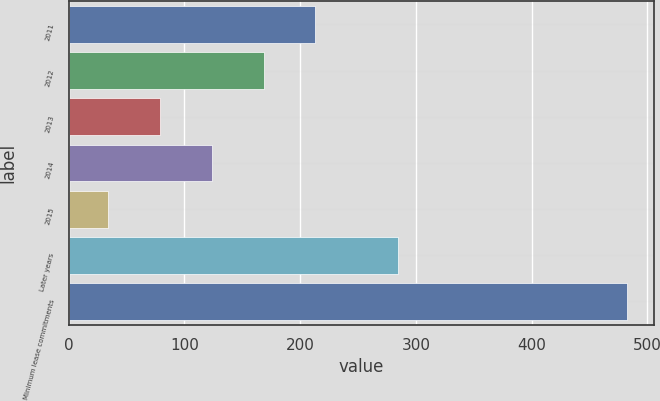Convert chart. <chart><loc_0><loc_0><loc_500><loc_500><bar_chart><fcel>2011<fcel>2012<fcel>2013<fcel>2014<fcel>2015<fcel>Later years<fcel>Minimum lease commitments<nl><fcel>213.2<fcel>168.4<fcel>78.8<fcel>123.6<fcel>34<fcel>285<fcel>482<nl></chart> 